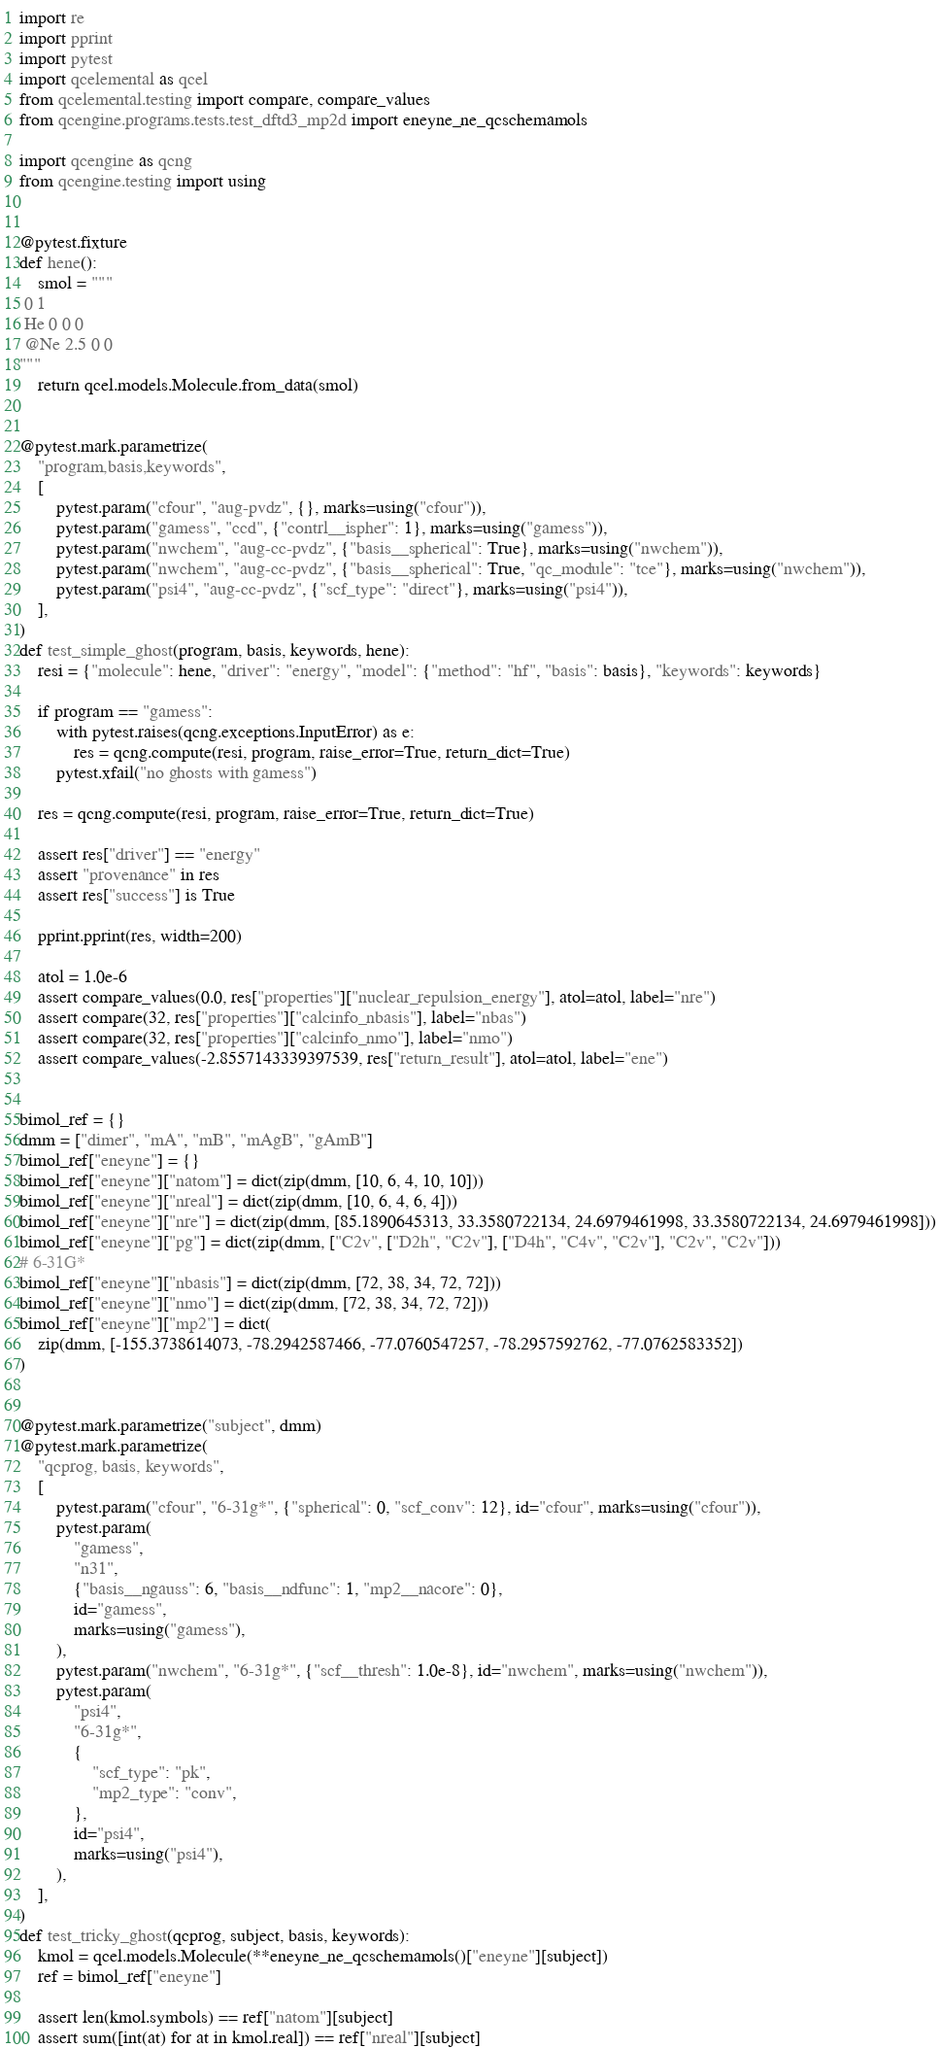<code> <loc_0><loc_0><loc_500><loc_500><_Python_>import re
import pprint
import pytest
import qcelemental as qcel
from qcelemental.testing import compare, compare_values
from qcengine.programs.tests.test_dftd3_mp2d import eneyne_ne_qcschemamols

import qcengine as qcng
from qcengine.testing import using


@pytest.fixture
def hene():
    smol = """
 0 1
 He 0 0 0
 @Ne 2.5 0 0
"""
    return qcel.models.Molecule.from_data(smol)


@pytest.mark.parametrize(
    "program,basis,keywords",
    [
        pytest.param("cfour", "aug-pvdz", {}, marks=using("cfour")),
        pytest.param("gamess", "ccd", {"contrl__ispher": 1}, marks=using("gamess")),
        pytest.param("nwchem", "aug-cc-pvdz", {"basis__spherical": True}, marks=using("nwchem")),
        pytest.param("nwchem", "aug-cc-pvdz", {"basis__spherical": True, "qc_module": "tce"}, marks=using("nwchem")),
        pytest.param("psi4", "aug-cc-pvdz", {"scf_type": "direct"}, marks=using("psi4")),
    ],
)
def test_simple_ghost(program, basis, keywords, hene):
    resi = {"molecule": hene, "driver": "energy", "model": {"method": "hf", "basis": basis}, "keywords": keywords}

    if program == "gamess":
        with pytest.raises(qcng.exceptions.InputError) as e:
            res = qcng.compute(resi, program, raise_error=True, return_dict=True)
        pytest.xfail("no ghosts with gamess")

    res = qcng.compute(resi, program, raise_error=True, return_dict=True)

    assert res["driver"] == "energy"
    assert "provenance" in res
    assert res["success"] is True

    pprint.pprint(res, width=200)

    atol = 1.0e-6
    assert compare_values(0.0, res["properties"]["nuclear_repulsion_energy"], atol=atol, label="nre")
    assert compare(32, res["properties"]["calcinfo_nbasis"], label="nbas")
    assert compare(32, res["properties"]["calcinfo_nmo"], label="nmo")
    assert compare_values(-2.8557143339397539, res["return_result"], atol=atol, label="ene")


bimol_ref = {}
dmm = ["dimer", "mA", "mB", "mAgB", "gAmB"]
bimol_ref["eneyne"] = {}
bimol_ref["eneyne"]["natom"] = dict(zip(dmm, [10, 6, 4, 10, 10]))
bimol_ref["eneyne"]["nreal"] = dict(zip(dmm, [10, 6, 4, 6, 4]))
bimol_ref["eneyne"]["nre"] = dict(zip(dmm, [85.1890645313, 33.3580722134, 24.6979461998, 33.3580722134, 24.6979461998]))
bimol_ref["eneyne"]["pg"] = dict(zip(dmm, ["C2v", ["D2h", "C2v"], ["D4h", "C4v", "C2v"], "C2v", "C2v"]))
# 6-31G*
bimol_ref["eneyne"]["nbasis"] = dict(zip(dmm, [72, 38, 34, 72, 72]))
bimol_ref["eneyne"]["nmo"] = dict(zip(dmm, [72, 38, 34, 72, 72]))
bimol_ref["eneyne"]["mp2"] = dict(
    zip(dmm, [-155.3738614073, -78.2942587466, -77.0760547257, -78.2957592762, -77.0762583352])
)


@pytest.mark.parametrize("subject", dmm)
@pytest.mark.parametrize(
    "qcprog, basis, keywords",
    [
        pytest.param("cfour", "6-31g*", {"spherical": 0, "scf_conv": 12}, id="cfour", marks=using("cfour")),
        pytest.param(
            "gamess",
            "n31",
            {"basis__ngauss": 6, "basis__ndfunc": 1, "mp2__nacore": 0},
            id="gamess",
            marks=using("gamess"),
        ),
        pytest.param("nwchem", "6-31g*", {"scf__thresh": 1.0e-8}, id="nwchem", marks=using("nwchem")),
        pytest.param(
            "psi4",
            "6-31g*",
            {
                "scf_type": "pk",
                "mp2_type": "conv",
            },
            id="psi4",
            marks=using("psi4"),
        ),
    ],
)
def test_tricky_ghost(qcprog, subject, basis, keywords):
    kmol = qcel.models.Molecule(**eneyne_ne_qcschemamols()["eneyne"][subject])
    ref = bimol_ref["eneyne"]

    assert len(kmol.symbols) == ref["natom"][subject]
    assert sum([int(at) for at in kmol.real]) == ref["nreal"][subject]
</code> 